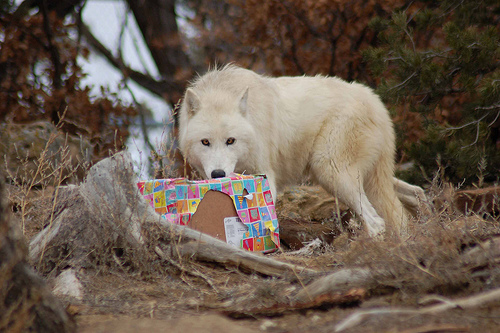<image>
Is there a wolf on the box? Yes. Looking at the image, I can see the wolf is positioned on top of the box, with the box providing support. Where is the wolf in relation to the gift? Is it on the gift? No. The wolf is not positioned on the gift. They may be near each other, but the wolf is not supported by or resting on top of the gift. Where is the box in relation to the animal? Is it on the animal? No. The box is not positioned on the animal. They may be near each other, but the box is not supported by or resting on top of the animal. Is the wolf in front of the gift? Yes. The wolf is positioned in front of the gift, appearing closer to the camera viewpoint. 